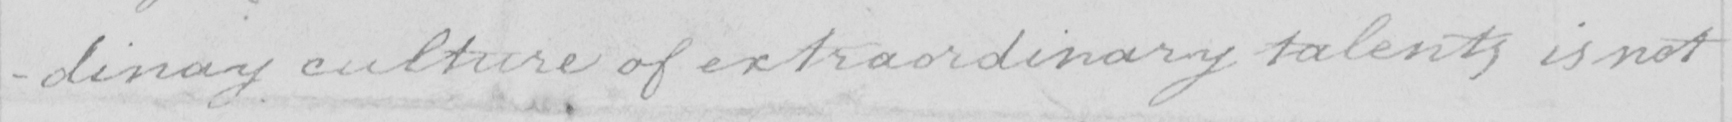Please transcribe the handwritten text in this image. -dinary culture of extraordinary talents is not 